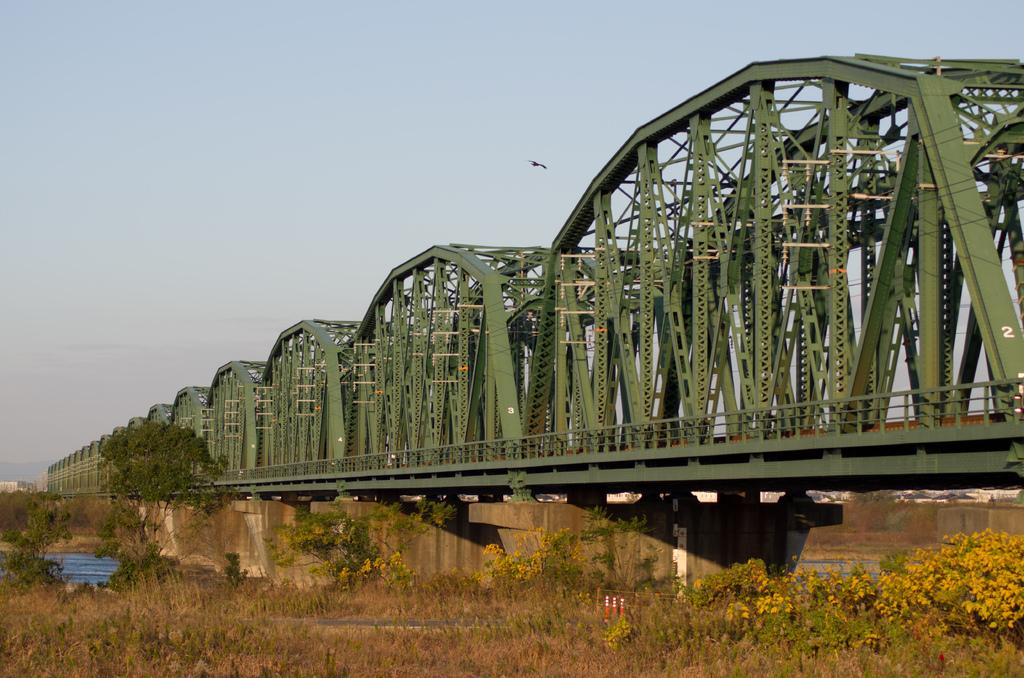What type of vegetation can be seen in the image? There are plants and trees in the image. What structure is located in the middle of the image? There is a bridge in the middle of the image. What is visible at the top of the image? The sky is visible at the top of the image. Can you tell me how many daughters are depicted in the image? There are no daughters present in the image. What type of fowl can be seen flying over the bridge in the image? There is no fowl present in the image; it only features plants, trees, a bridge, and the sky. 